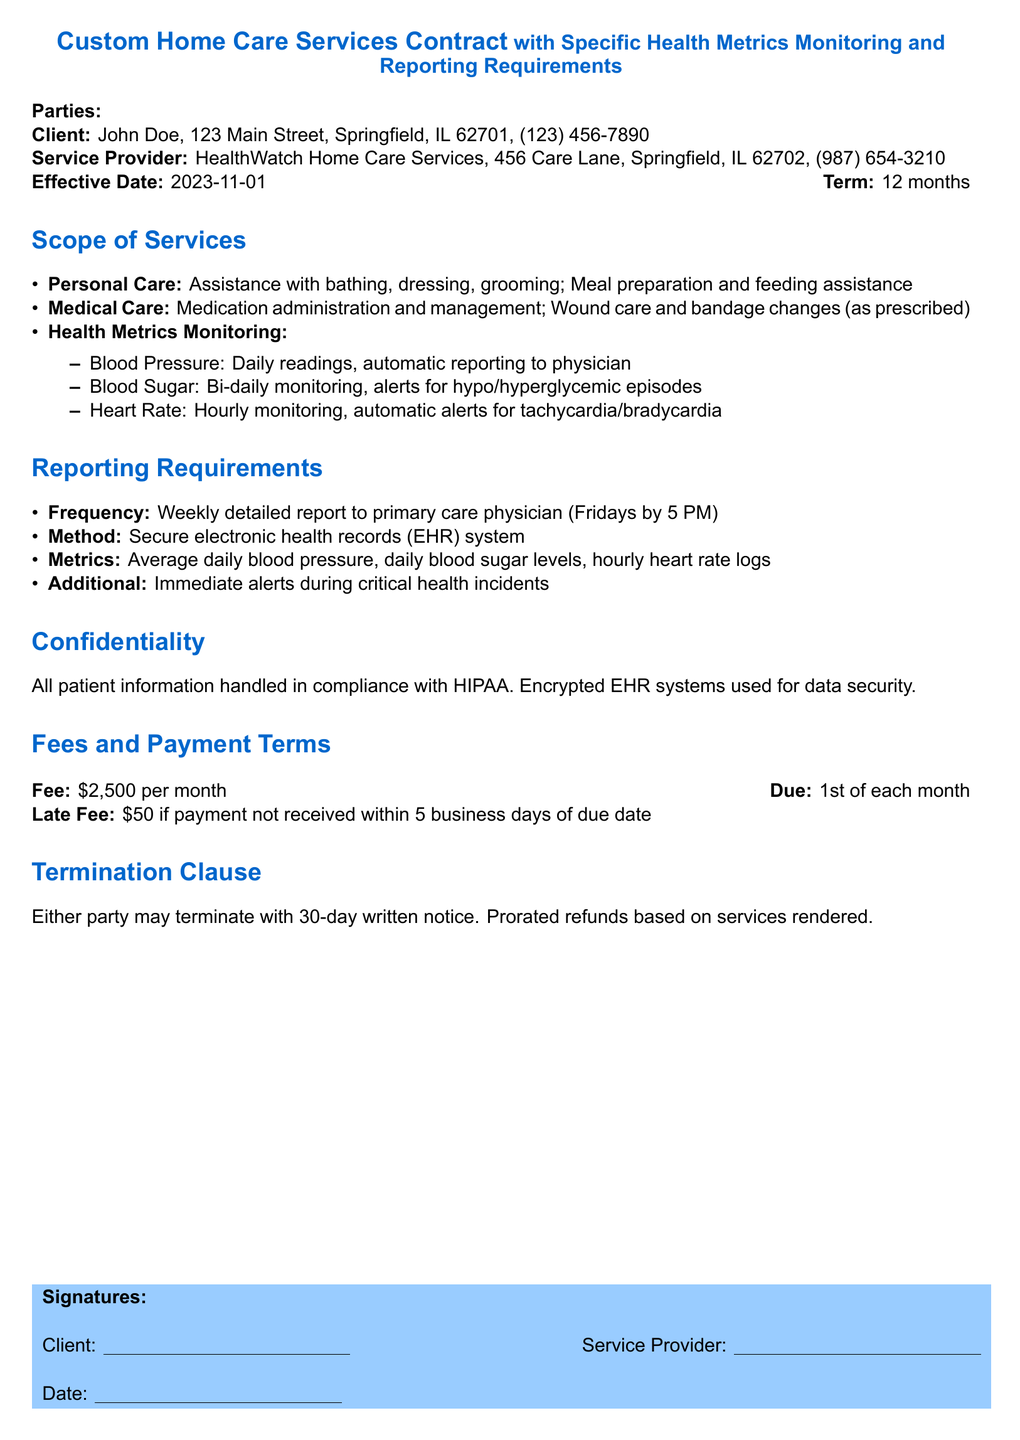What is the name of the client? The client is identified at the beginning of the document, stating the name "John Doe."
Answer: John Doe What is the effective date of the contract? The effective date is explicitly mentioned in the contract as "2023-11-01."
Answer: 2023-11-01 What is the monthly fee for the services? The fee is clearly stated in the Fees and Payment Terms section as "$2,500 per month."
Answer: $2,500 How often are blood pressure readings taken? Blood pressure monitoring frequency is specified as "Daily readings."
Answer: Daily readings When is the weekly report due to the primary care physician? The reporting frequency section mentions that the report is due "Fridays by 5 PM."
Answer: Fridays by 5 PM What is the late fee amount? The document specifies a late fee of "$50" if payment is not received on time.
Answer: $50 What methods are used to report health metrics? The method of reporting is stated as "Secure electronic health records (EHR) system."
Answer: Secure electronic health records (EHR) system What is required to terminate the contract? The termination clause indicates that a "30-day written notice" is required to terminate the contract.
Answer: 30-day written notice What are the health metrics monitored? A section lists the specific health metrics, which include blood pressure, blood sugar, and heart rate.
Answer: Blood pressure, blood sugar, heart rate 